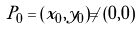<formula> <loc_0><loc_0><loc_500><loc_500>P _ { 0 } = ( x _ { 0 } , y _ { 0 } ) \neq ( 0 , 0 )</formula> 